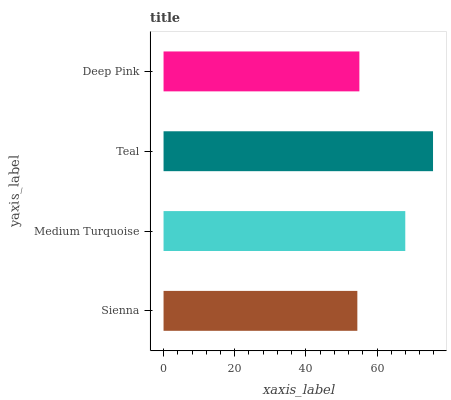Is Sienna the minimum?
Answer yes or no. Yes. Is Teal the maximum?
Answer yes or no. Yes. Is Medium Turquoise the minimum?
Answer yes or no. No. Is Medium Turquoise the maximum?
Answer yes or no. No. Is Medium Turquoise greater than Sienna?
Answer yes or no. Yes. Is Sienna less than Medium Turquoise?
Answer yes or no. Yes. Is Sienna greater than Medium Turquoise?
Answer yes or no. No. Is Medium Turquoise less than Sienna?
Answer yes or no. No. Is Medium Turquoise the high median?
Answer yes or no. Yes. Is Deep Pink the low median?
Answer yes or no. Yes. Is Teal the high median?
Answer yes or no. No. Is Sienna the low median?
Answer yes or no. No. 